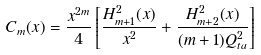Convert formula to latex. <formula><loc_0><loc_0><loc_500><loc_500>C _ { m } ( x ) = \frac { x ^ { 2 m } } { 4 } \left [ \frac { H _ { m + 1 } ^ { 2 } ( x ) } { x ^ { 2 } } + \frac { H _ { m + 2 } ^ { 2 } ( x ) } { ( m + 1 ) Q _ { t a } ^ { 2 } } \right ]</formula> 